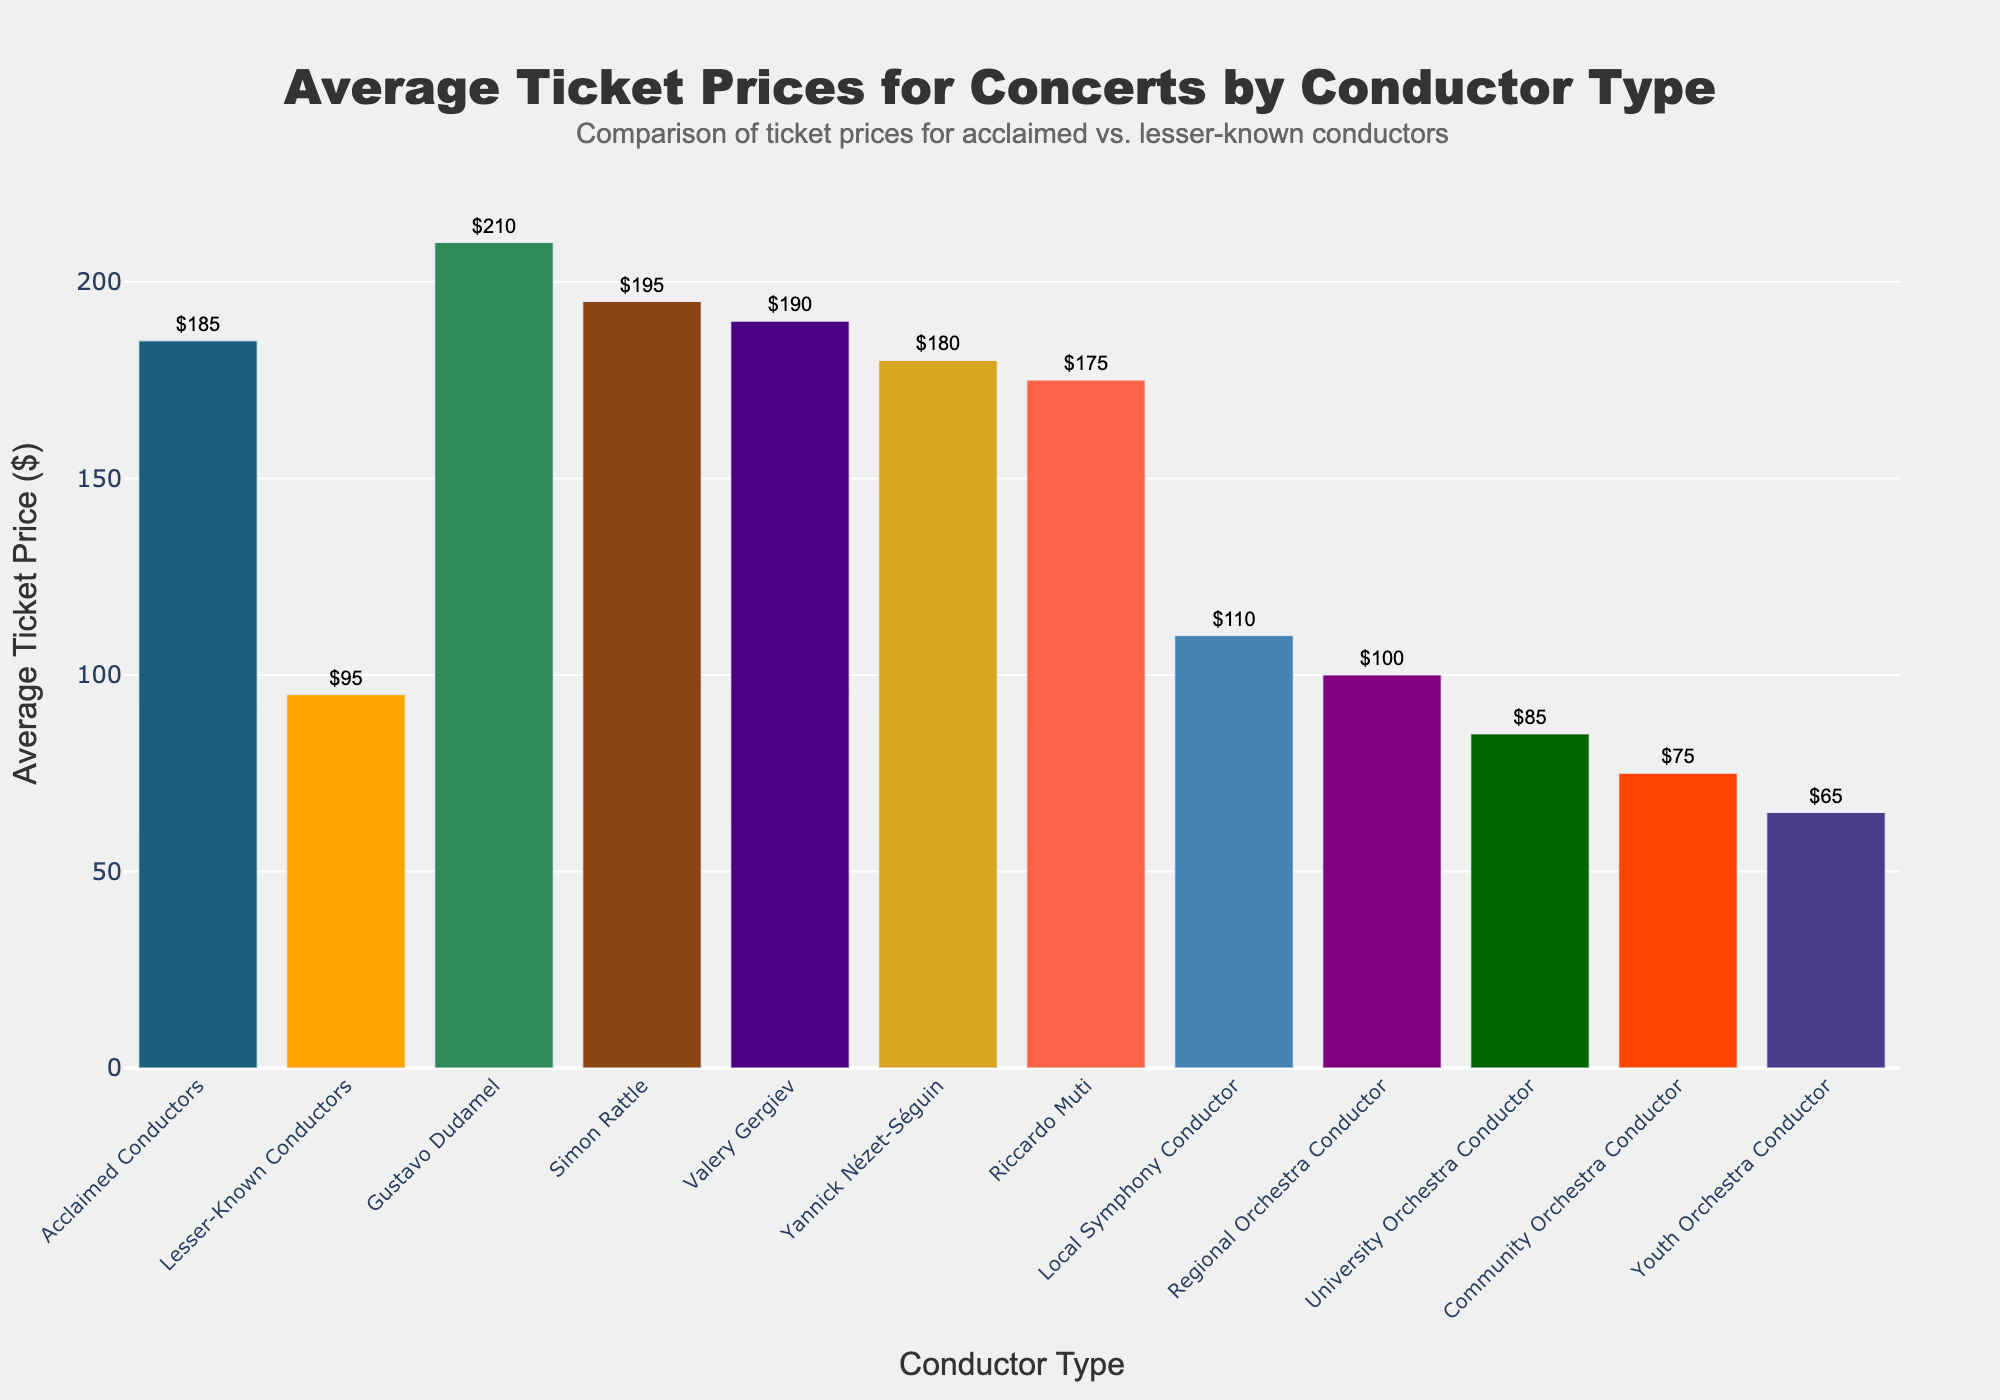Which conductor type has the highest average ticket price? The bar for Gustavo Dudamel is the highest among all conductor types presented. The height of the bar directly corresponds to the highest value, which is $210.
Answer: Gustavo Dudamel How much more expensive are tickets for concerts led by acclaimed conductors compared to those led by lesser-known conductors? The average ticket price for acclaimed conductors is $185, and for lesser-known conductors, it is $95. The difference between these two values is calculated by $185 - $95 = $90.
Answer: $90 What is the combined average ticket price for concerts led by Gustavo Dudamel, Simon Rattle, and Valery Gergiev? To find the combined average ticket price, sum the individual prices and then divide by the number of conductors. Combining $210 (Dudamel) + $195 (Rattle) + $190 (Gergiev) results in $595. Dividing by 3 gives $595 / 3 = $198.33.
Answer: $198.33 Which has a lower average ticket price, a university orchestra conductor or a community orchestra conductor? By comparing the two heights of the bars: University Orchestra Conductor has a ticket price of $85, while Community Orchestra Conductor has a ticket price of $75. Therefore, the community orchestra conductor has a lower average ticket price.
Answer: Community Orchestra Conductor What is the visual difference in bar heights between tickets for a regional orchestra conductor and a youth orchestra conductor? The average ticket price for a regional orchestra conductor is $100, and for a youth orchestra conductor, it is $65. The visual difference in bar heights represents $100 - $65 = $35.
Answer: $35 Which conductor types have average ticket prices below $100? The conductor types whose bars are at or below the $100 mark are lesser-known conductors ($95), university orchestra conductor ($85), community orchestra conductor ($75), and youth orchestra conductor ($65).
Answer: Lesser-Known Conductors, University Orchestra Conductor, Community Orchestra Conductor, Youth Orchestra Conductor Are tickets for concerts led by Riccardo Muti more expensive than those led by Yannick Nézet-Séguin? Based on the height of the bars, Riccardo Muti's average ticket price is $175 and Yannick Nézet-Séguin's is $180. $175 is less than $180.
Answer: No What is the difference in average ticket price between a local symphony conductor and an acclaimed conductor? The average ticket price for a local symphony conductor is $110, and for an acclaimed conductor, it is $185. The difference is calculated by $185 - $110 = $75.
Answer: $75 What is the range of average ticket prices for lesser-known conductors? The range for lesser-known conductors is from $65 (youth orchestra conductor) to $110 (local symphony conductor). The difference between these two values is $110 - $65 = $45.
Answer: $45 